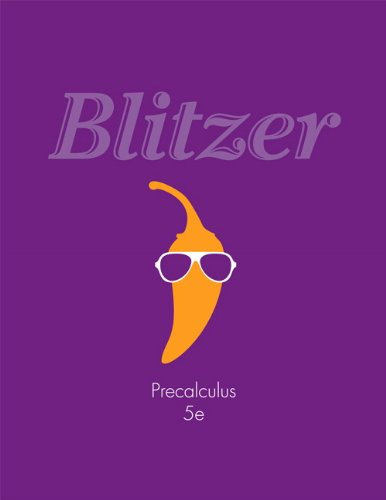What type of book is this? This book is an educational textbook focused on precalculus, a branch of mathematics, which is often used as preparatory material for students progressing to calculus. 